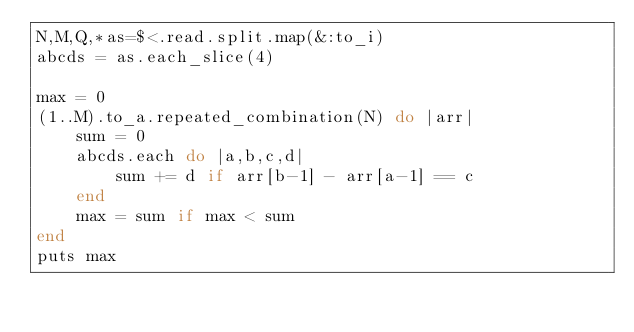<code> <loc_0><loc_0><loc_500><loc_500><_Ruby_>N,M,Q,*as=$<.read.split.map(&:to_i)
abcds = as.each_slice(4)

max = 0
(1..M).to_a.repeated_combination(N) do |arr|
    sum = 0
    abcds.each do |a,b,c,d|
        sum += d if arr[b-1] - arr[a-1] == c
    end
    max = sum if max < sum
end
puts max
</code> 